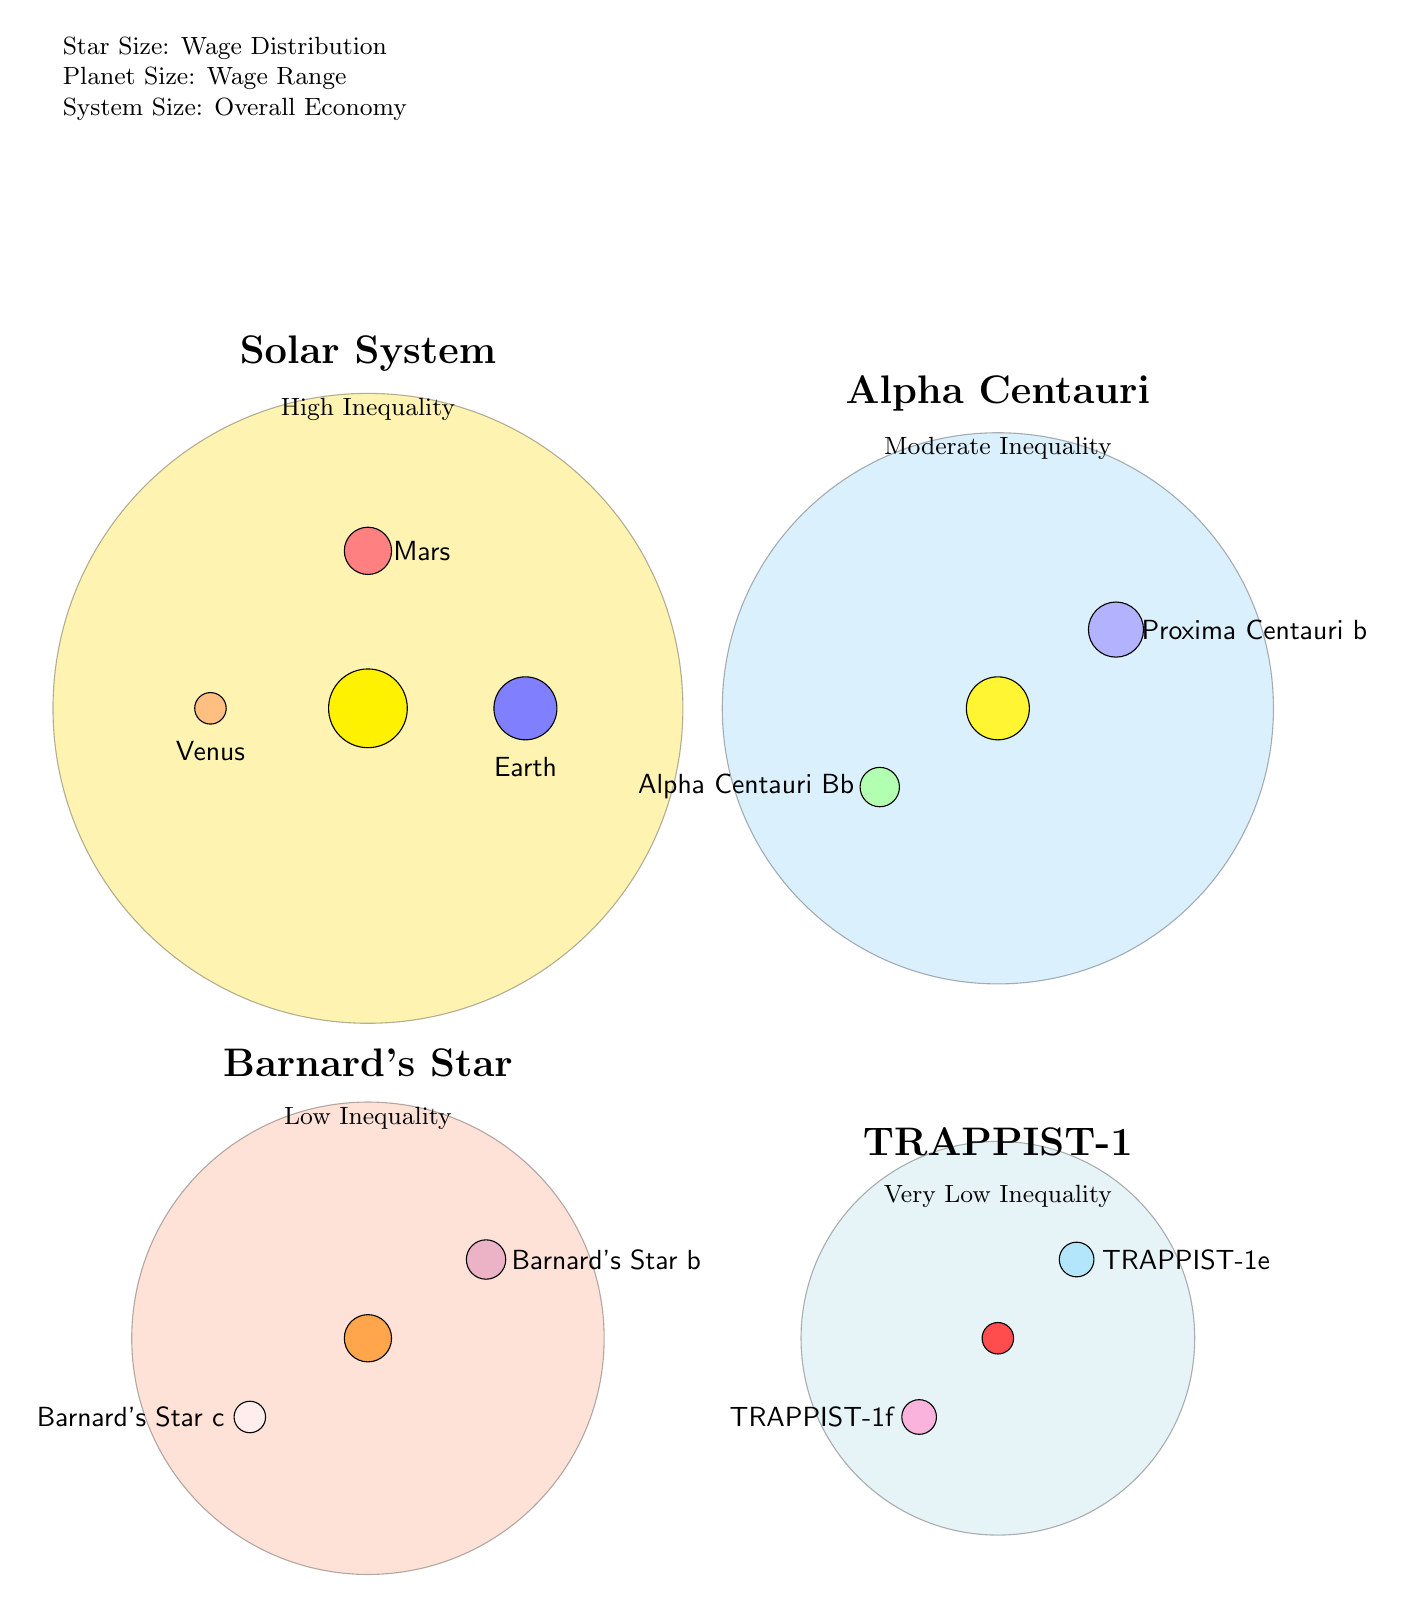What is the overall economy size of the Solar System? The Solar System is represented by a circle of radius 4cm in the diagram, indicating it has a larger economy size compared to others.
Answer: High Inequality What color represents the planet TRAPPIST-1e? The diagram features TRAPPIST-1e depicted as a circle filled with cyan!30, which stands for a moderate size compared to the other planets in the TRAPPIST-1 system.
Answer: Cyan Which star system has the smallest overall economy size? TRAPPIST-1 is depicted with a circle of radius 2.5cm, making it the smallest overall economy in the diagram.
Answer: TRAPPIST-1 How many planets are associated with Alpha Centauri? The diagram shows two small circles for planets orbiting Alpha Centauri, indicating its composition.
Answer: 2 What is the wage inequality status of Barnard's Star? Barnard's Star is labeled as having low inequality, as indicated within the diagram near its representation.
Answer: Low Inequality In terms of brightness, which star system has the brightest star? The Solar System's central star is depicted as the largest and brightest yellow circle, indicating it has the highest brightness.
Answer: Solar System What is the comparison of the inequality between TRAPPIST-1 and Barnard's Star? The diagram indicates TRAPPIST-1 has very low inequality while Barnard's Star has low inequality, thus TRAPPIST-1 has less inequality.
Answer: TRAPPIST-1 has less inequality What do the sizes of the planets represent in the diagram? The size of the planets in the diagram represents the wage range, which varies across different star systems.
Answer: Wage Range Which star system is represented as having moderate inequality? The Alpha Centauri system includes a label indicating it has moderate inequality, distinctly shown in the visual representation.
Answer: Alpha Centauri 